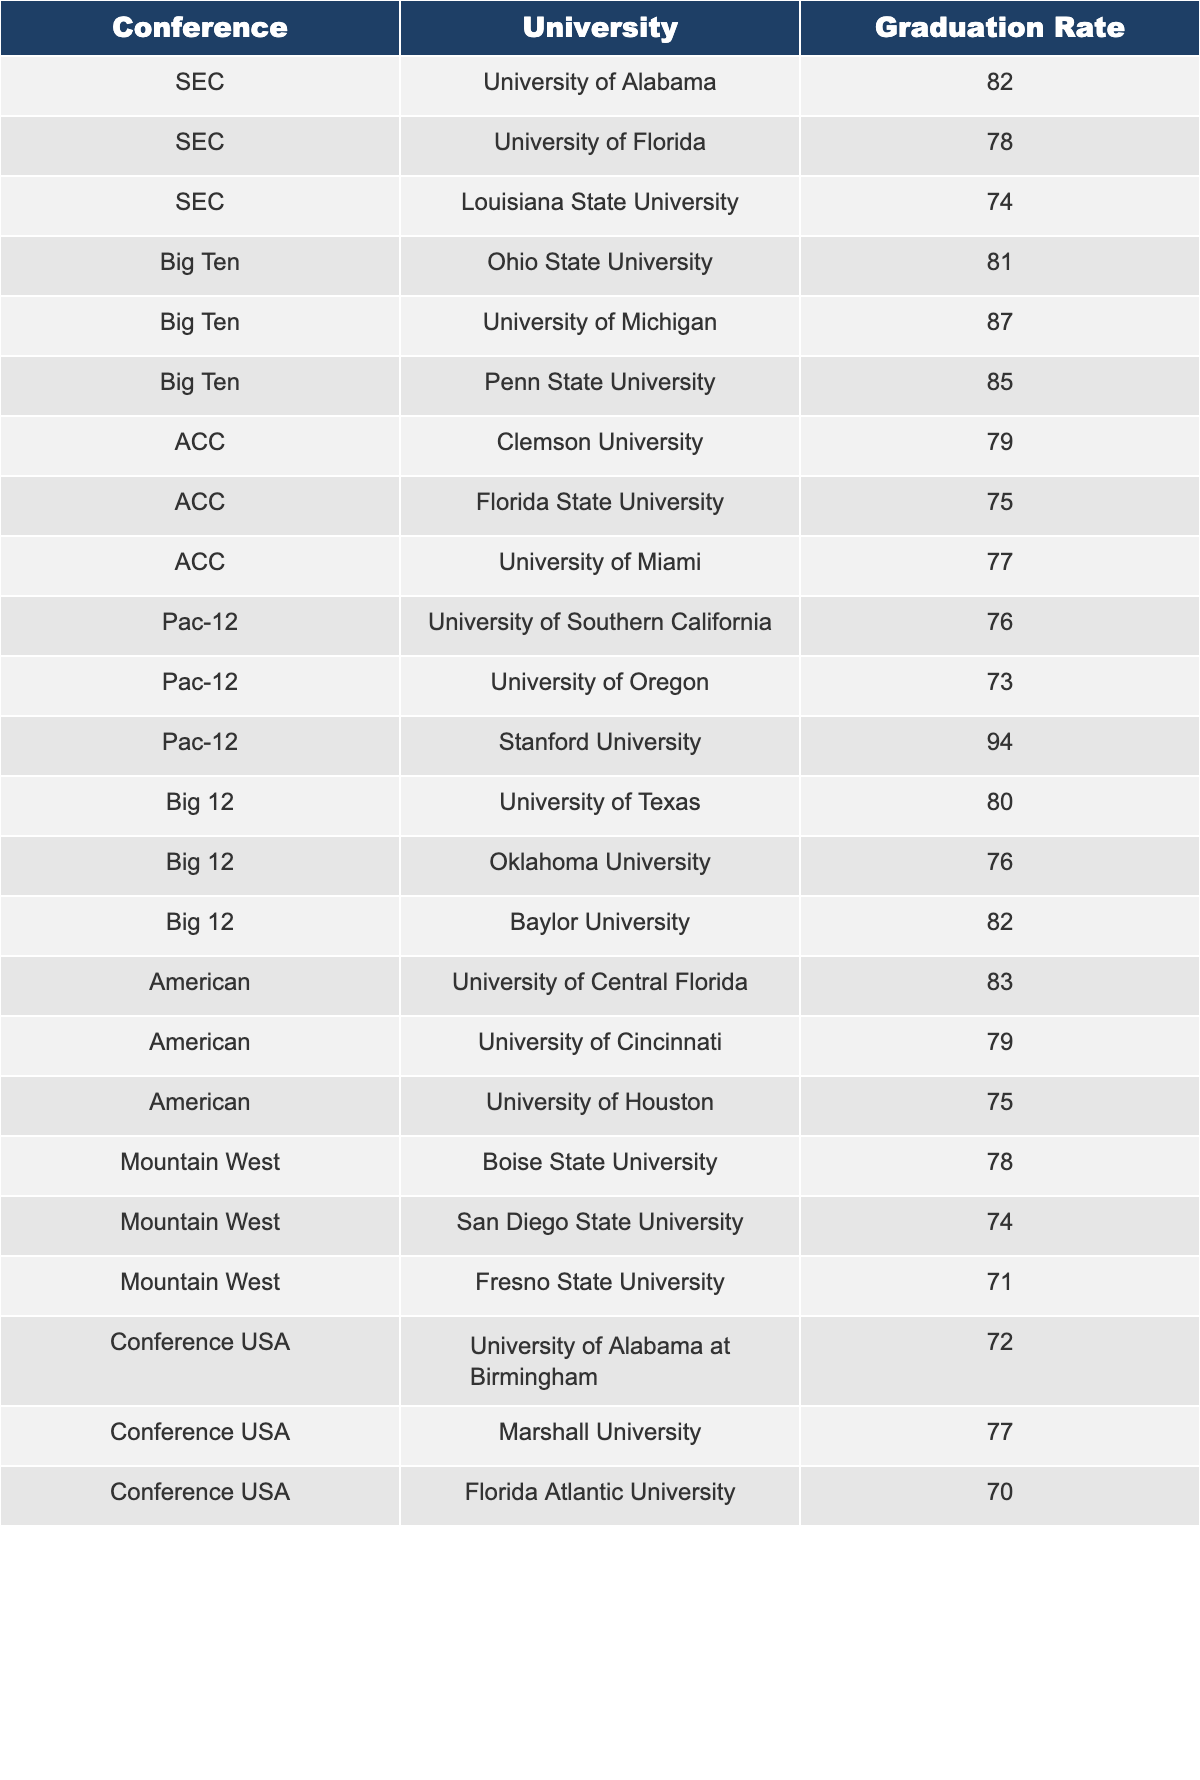What is the graduation rate of the University of Michigan? The table lists the graduation rates, and I can find the University of Michigan under the Big Ten conference. Its graduation rate is listed as 87.
Answer: 87 Which university in the Pac-12 has the highest graduation rate? Looking under the Pac-12 section of the table, I see Stanford University listed with a graduation rate of 94, which is the highest of all universities in that conference.
Answer: Stanford University What is the average graduation rate for universities in the SEC? To find the average graduation rate for the SEC, I will add the graduation rates of the universities in that conference: 82 (Alabama) + 78 (Florida) + 74 (LSU) = 234. There are three universities, so the average is 234 / 3 = 78.
Answer: 78 Is the graduation rate of the University of Texas higher than that of Florida State University? The graduation rate for the University of Texas is recorded as 80, while Florida State University has a graduation rate of 75. 80 is greater than 75, confirming that the University of Texas has a higher rate.
Answer: Yes How many universities in the Conference USA have graduation rates below 75? From the Conference USA section, I find three universities with rates below 75: University of Alabama at Birmingham (72), Florida Atlantic University (70), and Marshall University (77), which is above 75. Therefore, there are only two with rates below 75.
Answer: 2 What is the combined graduation rate of all Big 12 universities? The Big 12 universities listed are the University of Texas (80), Oklahoma University (76), and Baylor University (82). Adding these together gives a combined graduation rate of 80 + 76 + 82 = 238.
Answer: 238 Which conference has the lowest graduation rate, and what is that rate? To determine which conference has the lowest graduation rate, I will compare all rates listed. The lowest rate is found under the Mountain West conference with Fresno State University at 71. Thus, the Mountain West has the lowest rate.
Answer: Mountain West, 71 What is the difference between the highest and lowest graduation rates in the table? The highest graduation rate is Stanford University at 94, while the lowest is Florida Atlantic University at 70. The difference is calculated as 94 - 70 = 24.
Answer: 24 How many universities have graduation rates above 80? From the table, I can count the universities with rates above 80: University of Alabama (82), Ohio State University (81), University of Michigan (87), Penn State University (85), Stanford University (94), and Baylor University (82). This totals to six universities.
Answer: 6 